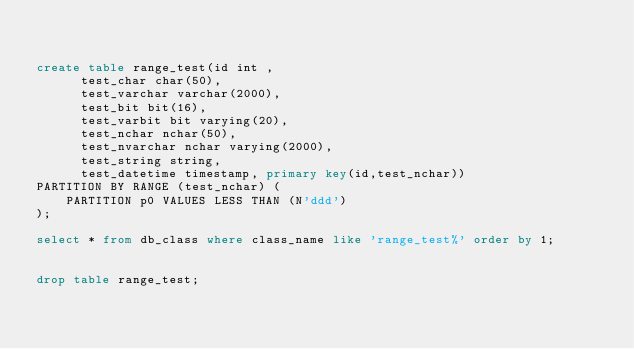<code> <loc_0><loc_0><loc_500><loc_500><_SQL_>

create table range_test(id int ,
			test_char char(50),
			test_varchar varchar(2000),
			test_bit bit(16),
			test_varbit bit varying(20),
			test_nchar nchar(50),
			test_nvarchar nchar varying(2000),
			test_string string,
			test_datetime timestamp, primary key(id,test_nchar))
PARTITION BY RANGE (test_nchar) (
    PARTITION p0 VALUES LESS THAN (N'ddd')
);

select * from db_class where class_name like 'range_test%' order by 1;


drop table range_test;
</code> 